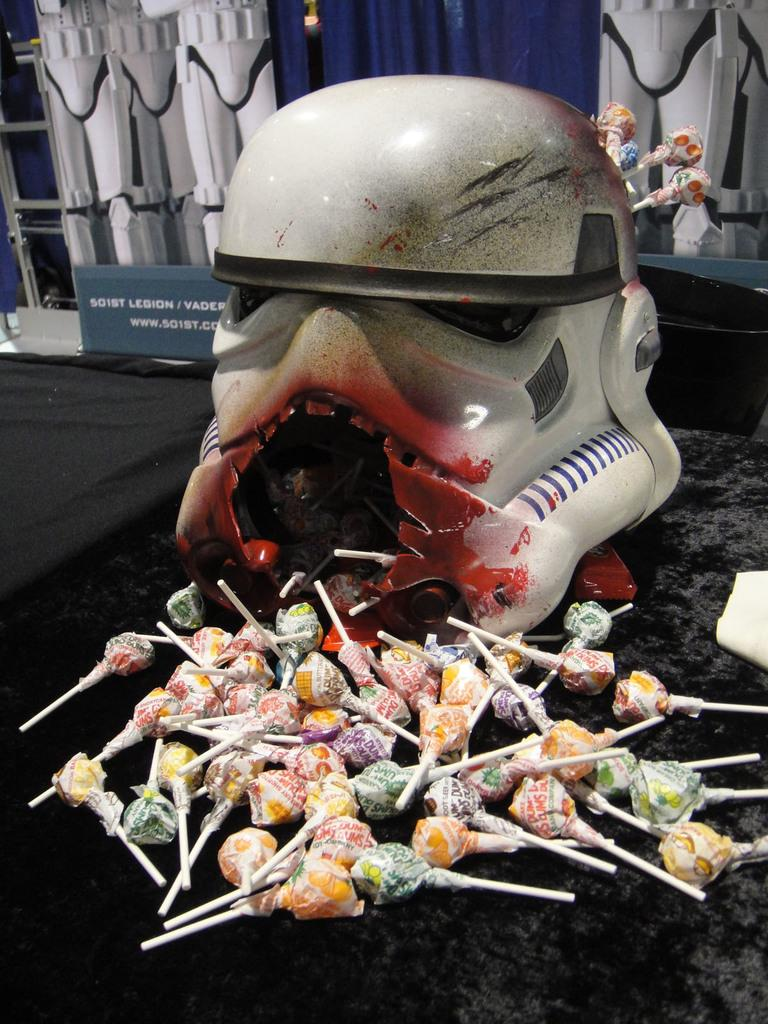What type of candy can be seen in the image? There are lollipops in the image. What artistic creation is present in the image? There is a sculpture in the image. What is the flat, rectangular object in the image? There is a board in the image. Can you describe any other objects visible in the background of the image? There are additional objects in the background of the image, but their specific details are not mentioned in the provided facts. What type of bike is present in the image? There is no bike present in the image. How does the sculpture show care for the environment in the image? The sculpture does not show care for the environment in the image, as there is no information provided about its subject matter or purpose. 